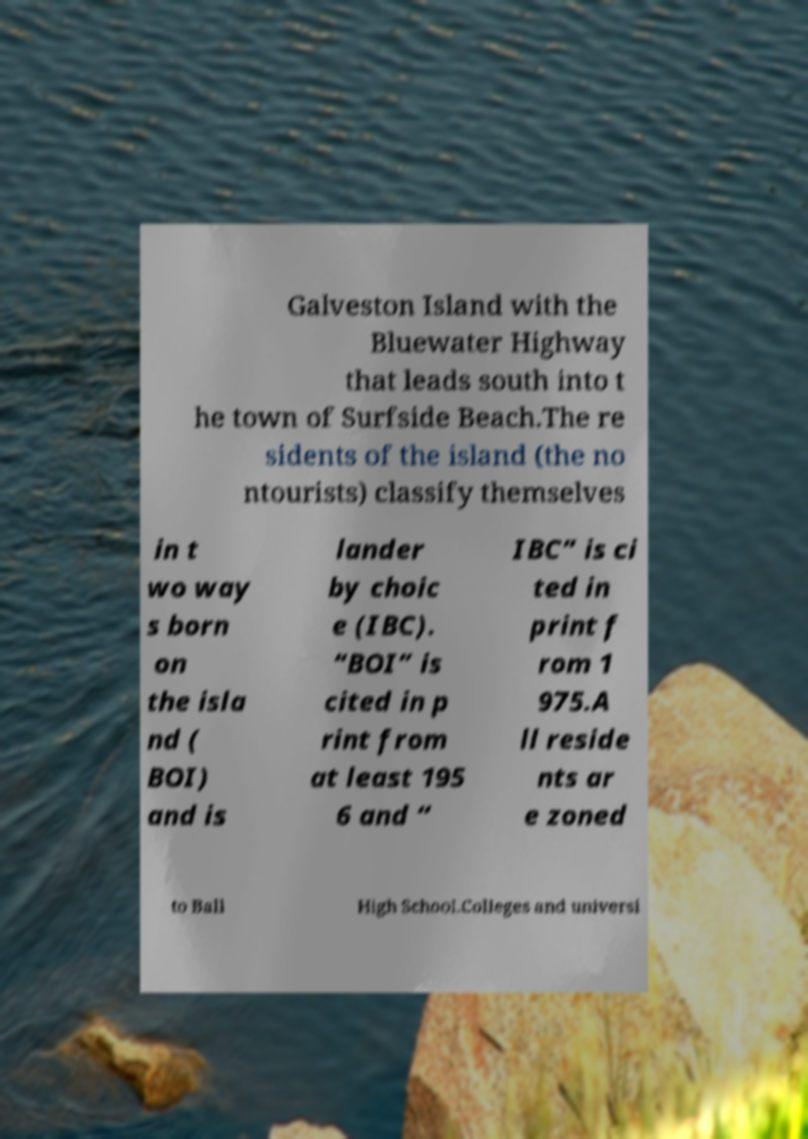What messages or text are displayed in this image? I need them in a readable, typed format. Galveston Island with the Bluewater Highway that leads south into t he town of Surfside Beach.The re sidents of the island (the no ntourists) classify themselves in t wo way s born on the isla nd ( BOI) and is lander by choic e (IBC). “BOI” is cited in p rint from at least 195 6 and “ IBC” is ci ted in print f rom 1 975.A ll reside nts ar e zoned to Ball High School.Colleges and universi 